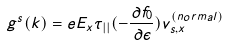Convert formula to latex. <formula><loc_0><loc_0><loc_500><loc_500>g ^ { s } ( { k } ) = e E _ { x } \tau _ { | | } ( - \frac { \partial f _ { 0 } } { \partial \epsilon } ) v _ { s , x } ^ { ( n o r m a l ) }</formula> 